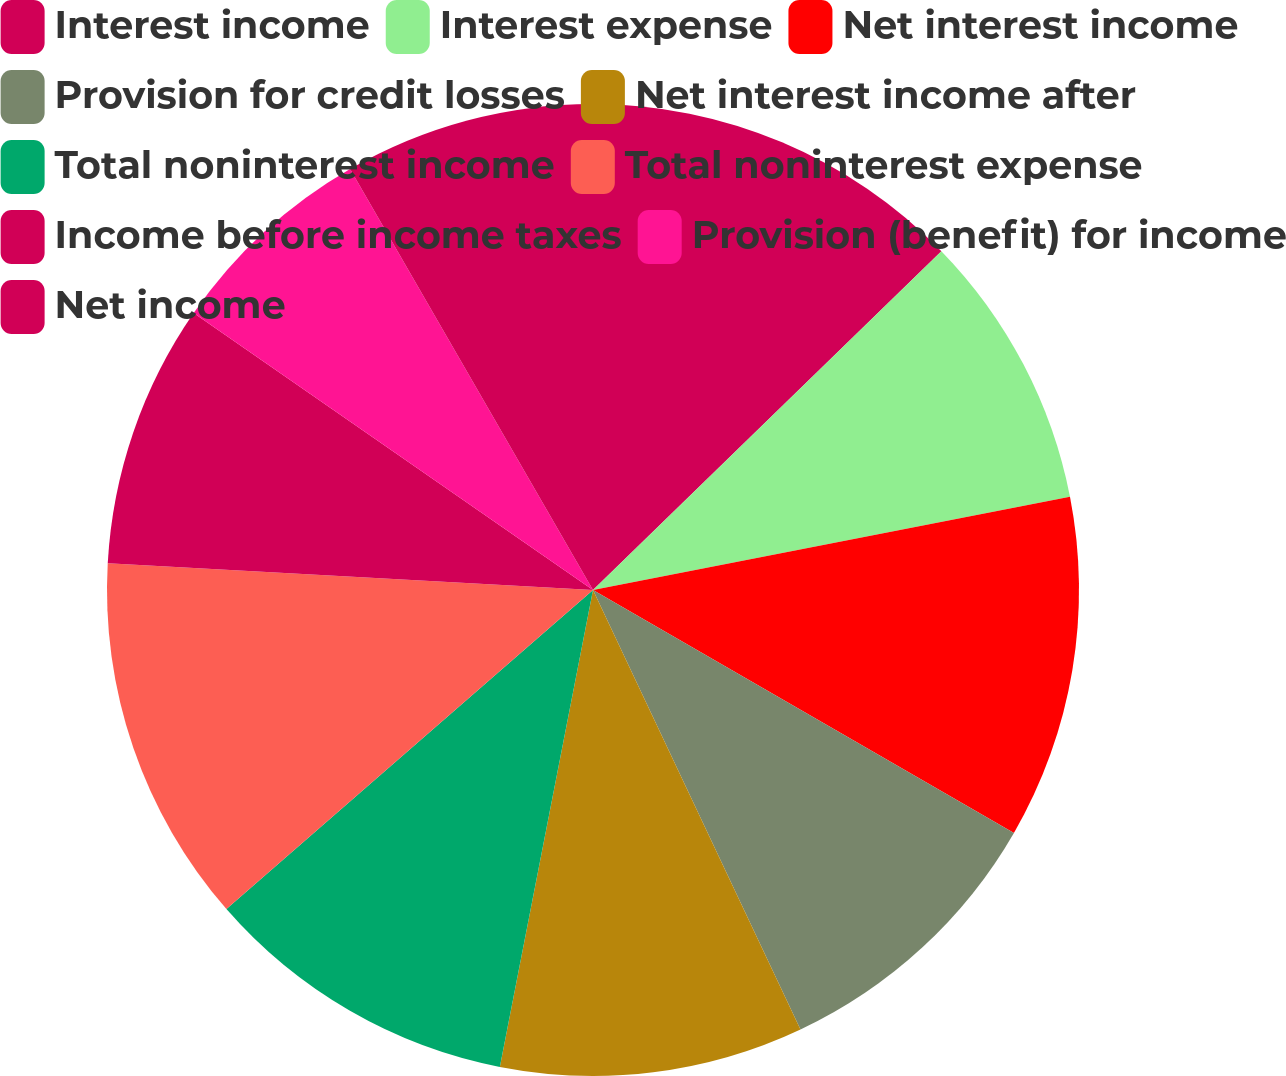Convert chart to OTSL. <chart><loc_0><loc_0><loc_500><loc_500><pie_chart><fcel>Interest income<fcel>Interest expense<fcel>Net interest income<fcel>Provision for credit losses<fcel>Net interest income after<fcel>Total noninterest income<fcel>Total noninterest expense<fcel>Income before income taxes<fcel>Provision (benefit) for income<fcel>Net income<nl><fcel>12.72%<fcel>9.21%<fcel>11.4%<fcel>9.65%<fcel>10.09%<fcel>10.53%<fcel>12.28%<fcel>8.77%<fcel>7.02%<fcel>8.33%<nl></chart> 